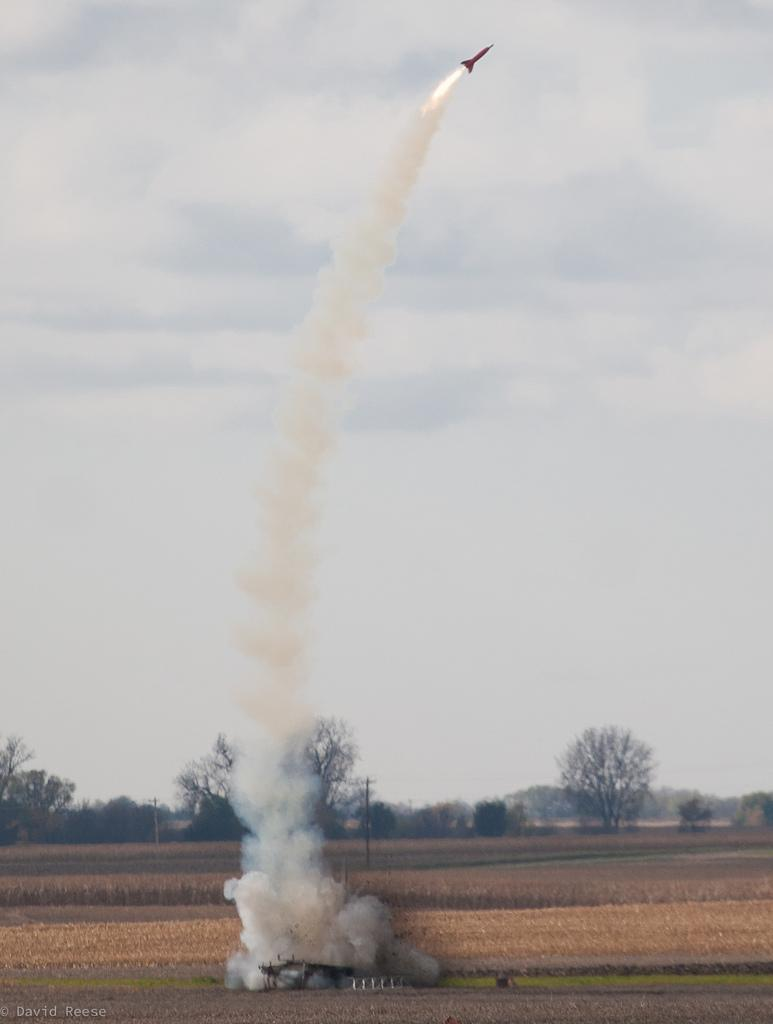What is happening in the image? There is a small rocket launch in the image. Where is the rocket launch taking place? The rocket launch is in a dry grass field. What can be seen in the sky during the rocket launch? A rocket is flying in the air with white smoke. What can be seen in the distance in the image? There are trees visible in the background of the image. What hopeful statement can be seen written on the rocket in the image? There is no statement visible on the rocket in the image; it is a rocket launch with a rocket flying in the air with white smoke. Can you see any stars in the image? There are no stars visible in the image; it is a rocket launch taking place in a dry grass field with trees in the background. 